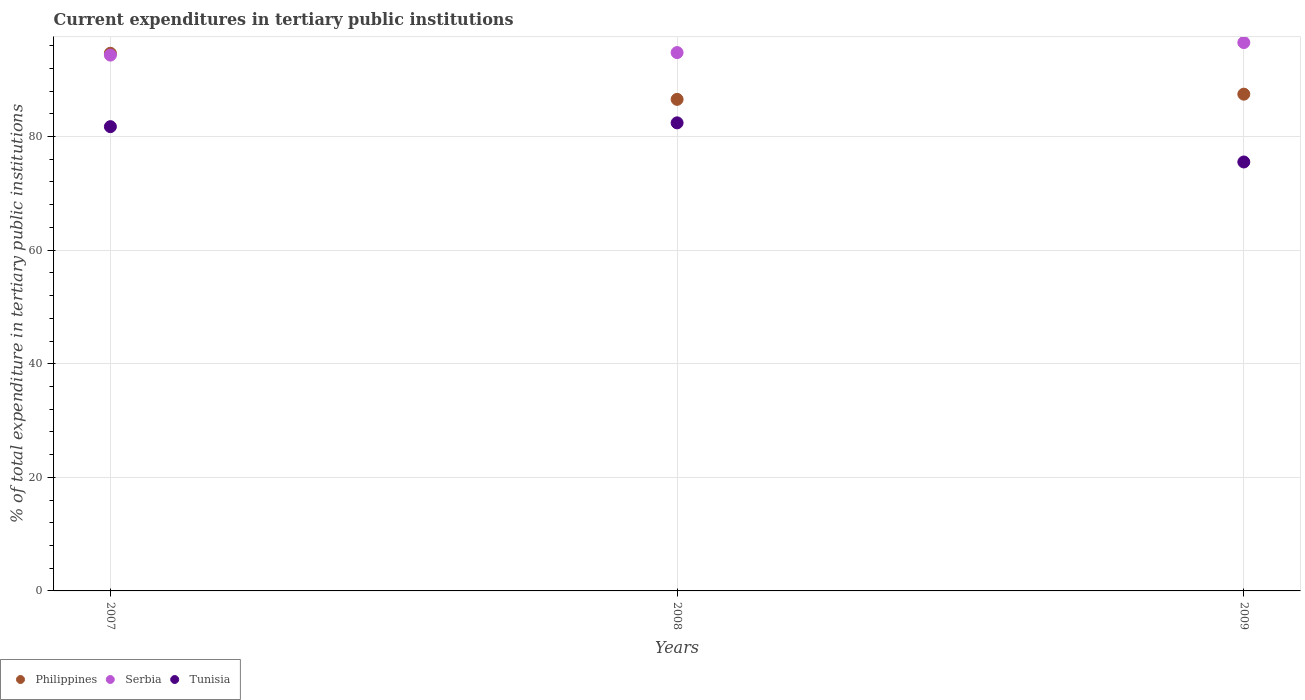What is the current expenditures in tertiary public institutions in Tunisia in 2007?
Ensure brevity in your answer.  81.74. Across all years, what is the maximum current expenditures in tertiary public institutions in Tunisia?
Offer a terse response. 82.41. Across all years, what is the minimum current expenditures in tertiary public institutions in Philippines?
Provide a succinct answer. 86.55. What is the total current expenditures in tertiary public institutions in Tunisia in the graph?
Offer a terse response. 239.68. What is the difference between the current expenditures in tertiary public institutions in Serbia in 2007 and that in 2008?
Your answer should be very brief. -0.45. What is the difference between the current expenditures in tertiary public institutions in Philippines in 2008 and the current expenditures in tertiary public institutions in Tunisia in 2009?
Keep it short and to the point. 11.03. What is the average current expenditures in tertiary public institutions in Serbia per year?
Make the answer very short. 95.23. In the year 2008, what is the difference between the current expenditures in tertiary public institutions in Philippines and current expenditures in tertiary public institutions in Serbia?
Your answer should be compact. -8.24. In how many years, is the current expenditures in tertiary public institutions in Tunisia greater than 76 %?
Ensure brevity in your answer.  2. What is the ratio of the current expenditures in tertiary public institutions in Serbia in 2007 to that in 2009?
Ensure brevity in your answer.  0.98. Is the current expenditures in tertiary public institutions in Philippines in 2007 less than that in 2009?
Provide a succinct answer. No. Is the difference between the current expenditures in tertiary public institutions in Philippines in 2007 and 2009 greater than the difference between the current expenditures in tertiary public institutions in Serbia in 2007 and 2009?
Provide a succinct answer. Yes. What is the difference between the highest and the second highest current expenditures in tertiary public institutions in Philippines?
Provide a short and direct response. 7.2. What is the difference between the highest and the lowest current expenditures in tertiary public institutions in Tunisia?
Offer a very short reply. 6.89. In how many years, is the current expenditures in tertiary public institutions in Philippines greater than the average current expenditures in tertiary public institutions in Philippines taken over all years?
Ensure brevity in your answer.  1. Is it the case that in every year, the sum of the current expenditures in tertiary public institutions in Tunisia and current expenditures in tertiary public institutions in Philippines  is greater than the current expenditures in tertiary public institutions in Serbia?
Offer a very short reply. Yes. Does the current expenditures in tertiary public institutions in Philippines monotonically increase over the years?
Offer a terse response. No. Is the current expenditures in tertiary public institutions in Serbia strictly less than the current expenditures in tertiary public institutions in Tunisia over the years?
Keep it short and to the point. No. What is the difference between two consecutive major ticks on the Y-axis?
Provide a short and direct response. 20. Does the graph contain any zero values?
Give a very brief answer. No. How are the legend labels stacked?
Ensure brevity in your answer.  Horizontal. What is the title of the graph?
Offer a very short reply. Current expenditures in tertiary public institutions. Does "Albania" appear as one of the legend labels in the graph?
Your answer should be very brief. No. What is the label or title of the Y-axis?
Your answer should be compact. % of total expenditure in tertiary public institutions. What is the % of total expenditure in tertiary public institutions of Philippines in 2007?
Provide a succinct answer. 94.66. What is the % of total expenditure in tertiary public institutions in Serbia in 2007?
Your response must be concise. 94.34. What is the % of total expenditure in tertiary public institutions in Tunisia in 2007?
Make the answer very short. 81.74. What is the % of total expenditure in tertiary public institutions in Philippines in 2008?
Keep it short and to the point. 86.55. What is the % of total expenditure in tertiary public institutions of Serbia in 2008?
Your answer should be compact. 94.79. What is the % of total expenditure in tertiary public institutions in Tunisia in 2008?
Your answer should be very brief. 82.41. What is the % of total expenditure in tertiary public institutions in Philippines in 2009?
Give a very brief answer. 87.46. What is the % of total expenditure in tertiary public institutions of Serbia in 2009?
Ensure brevity in your answer.  96.55. What is the % of total expenditure in tertiary public institutions in Tunisia in 2009?
Your answer should be compact. 75.52. Across all years, what is the maximum % of total expenditure in tertiary public institutions in Philippines?
Your response must be concise. 94.66. Across all years, what is the maximum % of total expenditure in tertiary public institutions in Serbia?
Your response must be concise. 96.55. Across all years, what is the maximum % of total expenditure in tertiary public institutions in Tunisia?
Offer a very short reply. 82.41. Across all years, what is the minimum % of total expenditure in tertiary public institutions in Philippines?
Your answer should be very brief. 86.55. Across all years, what is the minimum % of total expenditure in tertiary public institutions in Serbia?
Keep it short and to the point. 94.34. Across all years, what is the minimum % of total expenditure in tertiary public institutions in Tunisia?
Provide a short and direct response. 75.52. What is the total % of total expenditure in tertiary public institutions of Philippines in the graph?
Offer a terse response. 268.68. What is the total % of total expenditure in tertiary public institutions in Serbia in the graph?
Keep it short and to the point. 285.68. What is the total % of total expenditure in tertiary public institutions of Tunisia in the graph?
Make the answer very short. 239.68. What is the difference between the % of total expenditure in tertiary public institutions in Philippines in 2007 and that in 2008?
Give a very brief answer. 8.11. What is the difference between the % of total expenditure in tertiary public institutions in Serbia in 2007 and that in 2008?
Your response must be concise. -0.45. What is the difference between the % of total expenditure in tertiary public institutions in Tunisia in 2007 and that in 2008?
Provide a short and direct response. -0.67. What is the difference between the % of total expenditure in tertiary public institutions of Philippines in 2007 and that in 2009?
Your answer should be compact. 7.2. What is the difference between the % of total expenditure in tertiary public institutions in Serbia in 2007 and that in 2009?
Provide a short and direct response. -2.21. What is the difference between the % of total expenditure in tertiary public institutions of Tunisia in 2007 and that in 2009?
Your answer should be very brief. 6.22. What is the difference between the % of total expenditure in tertiary public institutions in Philippines in 2008 and that in 2009?
Ensure brevity in your answer.  -0.91. What is the difference between the % of total expenditure in tertiary public institutions of Serbia in 2008 and that in 2009?
Offer a terse response. -1.77. What is the difference between the % of total expenditure in tertiary public institutions of Tunisia in 2008 and that in 2009?
Your answer should be very brief. 6.89. What is the difference between the % of total expenditure in tertiary public institutions of Philippines in 2007 and the % of total expenditure in tertiary public institutions of Serbia in 2008?
Your answer should be very brief. -0.12. What is the difference between the % of total expenditure in tertiary public institutions of Philippines in 2007 and the % of total expenditure in tertiary public institutions of Tunisia in 2008?
Offer a terse response. 12.25. What is the difference between the % of total expenditure in tertiary public institutions of Serbia in 2007 and the % of total expenditure in tertiary public institutions of Tunisia in 2008?
Make the answer very short. 11.93. What is the difference between the % of total expenditure in tertiary public institutions in Philippines in 2007 and the % of total expenditure in tertiary public institutions in Serbia in 2009?
Your answer should be very brief. -1.89. What is the difference between the % of total expenditure in tertiary public institutions of Philippines in 2007 and the % of total expenditure in tertiary public institutions of Tunisia in 2009?
Provide a short and direct response. 19.14. What is the difference between the % of total expenditure in tertiary public institutions of Serbia in 2007 and the % of total expenditure in tertiary public institutions of Tunisia in 2009?
Your response must be concise. 18.82. What is the difference between the % of total expenditure in tertiary public institutions in Philippines in 2008 and the % of total expenditure in tertiary public institutions in Serbia in 2009?
Provide a short and direct response. -10. What is the difference between the % of total expenditure in tertiary public institutions of Philippines in 2008 and the % of total expenditure in tertiary public institutions of Tunisia in 2009?
Your answer should be very brief. 11.03. What is the difference between the % of total expenditure in tertiary public institutions in Serbia in 2008 and the % of total expenditure in tertiary public institutions in Tunisia in 2009?
Ensure brevity in your answer.  19.26. What is the average % of total expenditure in tertiary public institutions of Philippines per year?
Your response must be concise. 89.56. What is the average % of total expenditure in tertiary public institutions of Serbia per year?
Keep it short and to the point. 95.23. What is the average % of total expenditure in tertiary public institutions of Tunisia per year?
Your answer should be compact. 79.89. In the year 2007, what is the difference between the % of total expenditure in tertiary public institutions in Philippines and % of total expenditure in tertiary public institutions in Serbia?
Provide a short and direct response. 0.32. In the year 2007, what is the difference between the % of total expenditure in tertiary public institutions in Philippines and % of total expenditure in tertiary public institutions in Tunisia?
Your response must be concise. 12.92. In the year 2007, what is the difference between the % of total expenditure in tertiary public institutions of Serbia and % of total expenditure in tertiary public institutions of Tunisia?
Your answer should be compact. 12.6. In the year 2008, what is the difference between the % of total expenditure in tertiary public institutions in Philippines and % of total expenditure in tertiary public institutions in Serbia?
Make the answer very short. -8.24. In the year 2008, what is the difference between the % of total expenditure in tertiary public institutions in Philippines and % of total expenditure in tertiary public institutions in Tunisia?
Provide a succinct answer. 4.14. In the year 2008, what is the difference between the % of total expenditure in tertiary public institutions in Serbia and % of total expenditure in tertiary public institutions in Tunisia?
Your answer should be very brief. 12.37. In the year 2009, what is the difference between the % of total expenditure in tertiary public institutions in Philippines and % of total expenditure in tertiary public institutions in Serbia?
Keep it short and to the point. -9.09. In the year 2009, what is the difference between the % of total expenditure in tertiary public institutions in Philippines and % of total expenditure in tertiary public institutions in Tunisia?
Provide a short and direct response. 11.94. In the year 2009, what is the difference between the % of total expenditure in tertiary public institutions in Serbia and % of total expenditure in tertiary public institutions in Tunisia?
Offer a terse response. 21.03. What is the ratio of the % of total expenditure in tertiary public institutions of Philippines in 2007 to that in 2008?
Offer a very short reply. 1.09. What is the ratio of the % of total expenditure in tertiary public institutions of Serbia in 2007 to that in 2008?
Give a very brief answer. 1. What is the ratio of the % of total expenditure in tertiary public institutions of Tunisia in 2007 to that in 2008?
Provide a short and direct response. 0.99. What is the ratio of the % of total expenditure in tertiary public institutions of Philippines in 2007 to that in 2009?
Provide a short and direct response. 1.08. What is the ratio of the % of total expenditure in tertiary public institutions of Serbia in 2007 to that in 2009?
Your answer should be compact. 0.98. What is the ratio of the % of total expenditure in tertiary public institutions in Tunisia in 2007 to that in 2009?
Ensure brevity in your answer.  1.08. What is the ratio of the % of total expenditure in tertiary public institutions in Philippines in 2008 to that in 2009?
Keep it short and to the point. 0.99. What is the ratio of the % of total expenditure in tertiary public institutions of Serbia in 2008 to that in 2009?
Offer a very short reply. 0.98. What is the ratio of the % of total expenditure in tertiary public institutions of Tunisia in 2008 to that in 2009?
Your answer should be very brief. 1.09. What is the difference between the highest and the second highest % of total expenditure in tertiary public institutions of Philippines?
Provide a short and direct response. 7.2. What is the difference between the highest and the second highest % of total expenditure in tertiary public institutions in Serbia?
Provide a short and direct response. 1.77. What is the difference between the highest and the second highest % of total expenditure in tertiary public institutions in Tunisia?
Ensure brevity in your answer.  0.67. What is the difference between the highest and the lowest % of total expenditure in tertiary public institutions in Philippines?
Keep it short and to the point. 8.11. What is the difference between the highest and the lowest % of total expenditure in tertiary public institutions of Serbia?
Keep it short and to the point. 2.21. What is the difference between the highest and the lowest % of total expenditure in tertiary public institutions of Tunisia?
Provide a succinct answer. 6.89. 